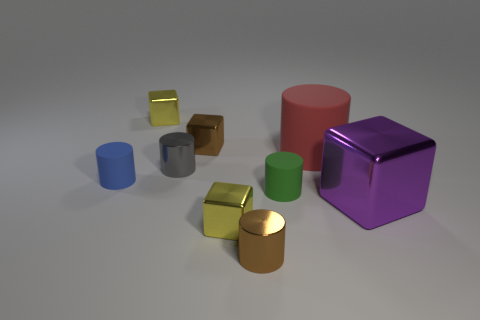Subtract 2 cylinders. How many cylinders are left? 3 Subtract all green cylinders. How many cylinders are left? 4 Subtract all purple cylinders. Subtract all gray blocks. How many cylinders are left? 5 Add 1 small metal blocks. How many objects exist? 10 Subtract all cylinders. How many objects are left? 4 Subtract all small blue rubber things. Subtract all tiny cylinders. How many objects are left? 4 Add 8 large purple blocks. How many large purple blocks are left? 9 Add 2 big purple shiny cubes. How many big purple shiny cubes exist? 3 Subtract 0 red cubes. How many objects are left? 9 